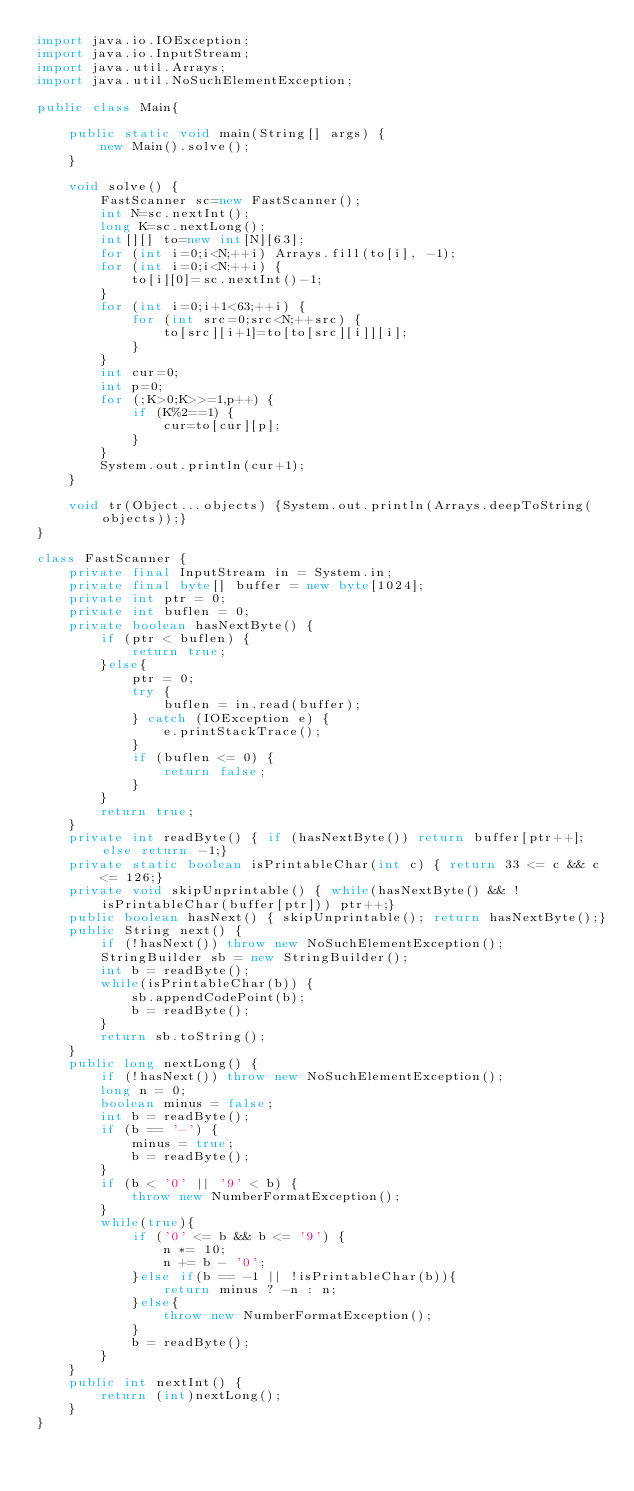Convert code to text. <code><loc_0><loc_0><loc_500><loc_500><_Java_>import java.io.IOException;
import java.io.InputStream;
import java.util.Arrays;
import java.util.NoSuchElementException;

public class Main{
	
	public static void main(String[] args) {
		new Main().solve();
	}
	
	void solve() {
		FastScanner sc=new FastScanner();
		int N=sc.nextInt();
		long K=sc.nextLong();
		int[][] to=new int[N][63];
		for (int i=0;i<N;++i) Arrays.fill(to[i], -1);
		for (int i=0;i<N;++i) {
			to[i][0]=sc.nextInt()-1;
		}
		for (int i=0;i+1<63;++i) {
			for (int src=0;src<N;++src) {
				to[src][i+1]=to[to[src][i]][i];
			}
		}
		int cur=0;
		int p=0;
		for (;K>0;K>>=1,p++) {
			if (K%2==1) {
				cur=to[cur][p];
			}
 		}
		System.out.println(cur+1);
	}
	
	void tr(Object...objects) {System.out.println(Arrays.deepToString(objects));}
}

class FastScanner {
    private final InputStream in = System.in;
    private final byte[] buffer = new byte[1024];
    private int ptr = 0;
    private int buflen = 0;
    private boolean hasNextByte() {
        if (ptr < buflen) {
            return true;
        }else{
            ptr = 0;
            try {
                buflen = in.read(buffer);
            } catch (IOException e) {
                e.printStackTrace();
            }
            if (buflen <= 0) {
                return false;
            }
        }
        return true;
    }
    private int readByte() { if (hasNextByte()) return buffer[ptr++]; else return -1;}
    private static boolean isPrintableChar(int c) { return 33 <= c && c <= 126;}
    private void skipUnprintable() { while(hasNextByte() && !isPrintableChar(buffer[ptr])) ptr++;}
    public boolean hasNext() { skipUnprintable(); return hasNextByte();}
    public String next() {
        if (!hasNext()) throw new NoSuchElementException();
        StringBuilder sb = new StringBuilder();
        int b = readByte();
        while(isPrintableChar(b)) {
            sb.appendCodePoint(b);
            b = readByte();
        }
        return sb.toString();
    }
    public long nextLong() {
        if (!hasNext()) throw new NoSuchElementException();
        long n = 0;
        boolean minus = false;
        int b = readByte();
        if (b == '-') {
            minus = true;
            b = readByte();
        }
        if (b < '0' || '9' < b) {
            throw new NumberFormatException();
        }
        while(true){
            if ('0' <= b && b <= '9') {
                n *= 10;
                n += b - '0';
            }else if(b == -1 || !isPrintableChar(b)){
                return minus ? -n : n;
            }else{
                throw new NumberFormatException();
            }
            b = readByte();
        }
    }
    public int nextInt() {
    	return (int)nextLong();
    }
}
</code> 